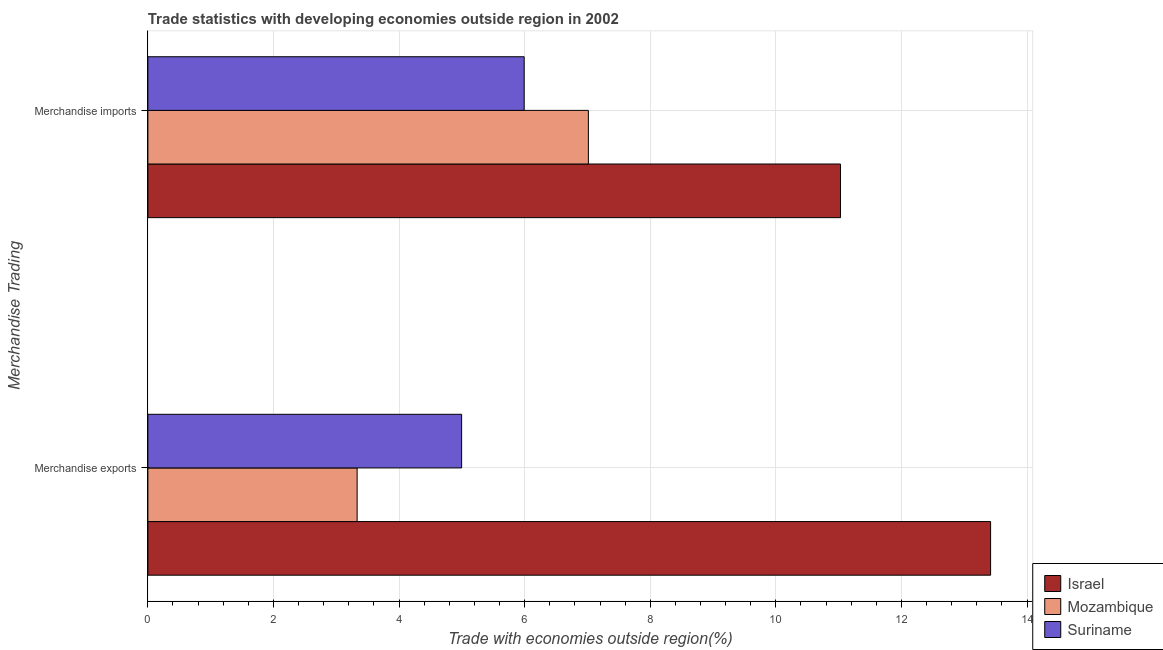How many different coloured bars are there?
Offer a terse response. 3. How many groups of bars are there?
Provide a succinct answer. 2. Are the number of bars on each tick of the Y-axis equal?
Your answer should be compact. Yes. How many bars are there on the 2nd tick from the bottom?
Provide a succinct answer. 3. What is the label of the 1st group of bars from the top?
Your response must be concise. Merchandise imports. What is the merchandise imports in Mozambique?
Your answer should be very brief. 7.01. Across all countries, what is the maximum merchandise exports?
Offer a very short reply. 13.42. Across all countries, what is the minimum merchandise exports?
Your answer should be very brief. 3.33. In which country was the merchandise exports maximum?
Provide a short and direct response. Israel. In which country was the merchandise imports minimum?
Your answer should be very brief. Suriname. What is the total merchandise exports in the graph?
Make the answer very short. 21.75. What is the difference between the merchandise exports in Israel and that in Mozambique?
Offer a very short reply. 10.09. What is the difference between the merchandise exports in Israel and the merchandise imports in Mozambique?
Offer a terse response. 6.41. What is the average merchandise imports per country?
Provide a succinct answer. 8.01. What is the difference between the merchandise imports and merchandise exports in Mozambique?
Give a very brief answer. 3.68. In how many countries, is the merchandise imports greater than 12.4 %?
Offer a very short reply. 0. What is the ratio of the merchandise imports in Israel to that in Suriname?
Make the answer very short. 1.84. Is the merchandise imports in Mozambique less than that in Israel?
Provide a short and direct response. Yes. What does the 2nd bar from the top in Merchandise imports represents?
Make the answer very short. Mozambique. What does the 3rd bar from the bottom in Merchandise imports represents?
Offer a terse response. Suriname. How many countries are there in the graph?
Make the answer very short. 3. How are the legend labels stacked?
Offer a terse response. Vertical. What is the title of the graph?
Provide a succinct answer. Trade statistics with developing economies outside region in 2002. What is the label or title of the X-axis?
Provide a short and direct response. Trade with economies outside region(%). What is the label or title of the Y-axis?
Offer a very short reply. Merchandise Trading. What is the Trade with economies outside region(%) in Israel in Merchandise exports?
Offer a very short reply. 13.42. What is the Trade with economies outside region(%) of Mozambique in Merchandise exports?
Make the answer very short. 3.33. What is the Trade with economies outside region(%) of Suriname in Merchandise exports?
Provide a short and direct response. 5. What is the Trade with economies outside region(%) in Israel in Merchandise imports?
Offer a very short reply. 11.03. What is the Trade with economies outside region(%) of Mozambique in Merchandise imports?
Offer a very short reply. 7.01. What is the Trade with economies outside region(%) of Suriname in Merchandise imports?
Your response must be concise. 5.99. Across all Merchandise Trading, what is the maximum Trade with economies outside region(%) of Israel?
Your answer should be compact. 13.42. Across all Merchandise Trading, what is the maximum Trade with economies outside region(%) of Mozambique?
Give a very brief answer. 7.01. Across all Merchandise Trading, what is the maximum Trade with economies outside region(%) in Suriname?
Keep it short and to the point. 5.99. Across all Merchandise Trading, what is the minimum Trade with economies outside region(%) of Israel?
Your answer should be very brief. 11.03. Across all Merchandise Trading, what is the minimum Trade with economies outside region(%) of Mozambique?
Offer a terse response. 3.33. Across all Merchandise Trading, what is the minimum Trade with economies outside region(%) in Suriname?
Offer a terse response. 5. What is the total Trade with economies outside region(%) in Israel in the graph?
Keep it short and to the point. 24.45. What is the total Trade with economies outside region(%) of Mozambique in the graph?
Give a very brief answer. 10.35. What is the total Trade with economies outside region(%) in Suriname in the graph?
Make the answer very short. 10.99. What is the difference between the Trade with economies outside region(%) of Israel in Merchandise exports and that in Merchandise imports?
Provide a short and direct response. 2.39. What is the difference between the Trade with economies outside region(%) in Mozambique in Merchandise exports and that in Merchandise imports?
Provide a short and direct response. -3.68. What is the difference between the Trade with economies outside region(%) of Suriname in Merchandise exports and that in Merchandise imports?
Offer a terse response. -1. What is the difference between the Trade with economies outside region(%) in Israel in Merchandise exports and the Trade with economies outside region(%) in Mozambique in Merchandise imports?
Make the answer very short. 6.41. What is the difference between the Trade with economies outside region(%) in Israel in Merchandise exports and the Trade with economies outside region(%) in Suriname in Merchandise imports?
Your answer should be compact. 7.43. What is the difference between the Trade with economies outside region(%) of Mozambique in Merchandise exports and the Trade with economies outside region(%) of Suriname in Merchandise imports?
Ensure brevity in your answer.  -2.66. What is the average Trade with economies outside region(%) of Israel per Merchandise Trading?
Ensure brevity in your answer.  12.23. What is the average Trade with economies outside region(%) of Mozambique per Merchandise Trading?
Provide a succinct answer. 5.17. What is the average Trade with economies outside region(%) of Suriname per Merchandise Trading?
Offer a very short reply. 5.49. What is the difference between the Trade with economies outside region(%) in Israel and Trade with economies outside region(%) in Mozambique in Merchandise exports?
Make the answer very short. 10.09. What is the difference between the Trade with economies outside region(%) of Israel and Trade with economies outside region(%) of Suriname in Merchandise exports?
Your answer should be compact. 8.42. What is the difference between the Trade with economies outside region(%) of Mozambique and Trade with economies outside region(%) of Suriname in Merchandise exports?
Your answer should be compact. -1.66. What is the difference between the Trade with economies outside region(%) of Israel and Trade with economies outside region(%) of Mozambique in Merchandise imports?
Provide a succinct answer. 4.02. What is the difference between the Trade with economies outside region(%) in Israel and Trade with economies outside region(%) in Suriname in Merchandise imports?
Offer a very short reply. 5.04. What is the difference between the Trade with economies outside region(%) of Mozambique and Trade with economies outside region(%) of Suriname in Merchandise imports?
Provide a short and direct response. 1.02. What is the ratio of the Trade with economies outside region(%) in Israel in Merchandise exports to that in Merchandise imports?
Provide a short and direct response. 1.22. What is the ratio of the Trade with economies outside region(%) of Mozambique in Merchandise exports to that in Merchandise imports?
Provide a short and direct response. 0.47. What is the ratio of the Trade with economies outside region(%) of Suriname in Merchandise exports to that in Merchandise imports?
Give a very brief answer. 0.83. What is the difference between the highest and the second highest Trade with economies outside region(%) of Israel?
Keep it short and to the point. 2.39. What is the difference between the highest and the second highest Trade with economies outside region(%) of Mozambique?
Keep it short and to the point. 3.68. What is the difference between the highest and the lowest Trade with economies outside region(%) in Israel?
Offer a terse response. 2.39. What is the difference between the highest and the lowest Trade with economies outside region(%) of Mozambique?
Your response must be concise. 3.68. 